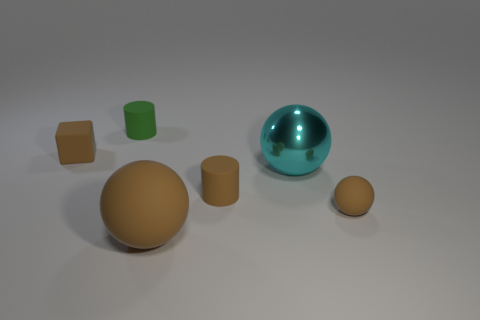Subtract all big spheres. How many spheres are left? 1 Subtract all cubes. How many objects are left? 5 Add 3 cubes. How many objects exist? 9 Subtract all green cylinders. How many cylinders are left? 1 Subtract 1 spheres. How many spheres are left? 2 Subtract all red cylinders. How many brown balls are left? 2 Add 3 large cyan shiny spheres. How many large cyan shiny spheres are left? 4 Add 5 large shiny things. How many large shiny things exist? 6 Subtract 1 cyan balls. How many objects are left? 5 Subtract all blue spheres. Subtract all cyan blocks. How many spheres are left? 3 